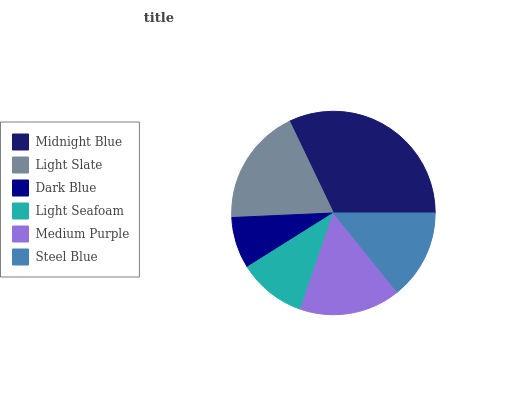Is Dark Blue the minimum?
Answer yes or no. Yes. Is Midnight Blue the maximum?
Answer yes or no. Yes. Is Light Slate the minimum?
Answer yes or no. No. Is Light Slate the maximum?
Answer yes or no. No. Is Midnight Blue greater than Light Slate?
Answer yes or no. Yes. Is Light Slate less than Midnight Blue?
Answer yes or no. Yes. Is Light Slate greater than Midnight Blue?
Answer yes or no. No. Is Midnight Blue less than Light Slate?
Answer yes or no. No. Is Medium Purple the high median?
Answer yes or no. Yes. Is Steel Blue the low median?
Answer yes or no. Yes. Is Light Slate the high median?
Answer yes or no. No. Is Dark Blue the low median?
Answer yes or no. No. 